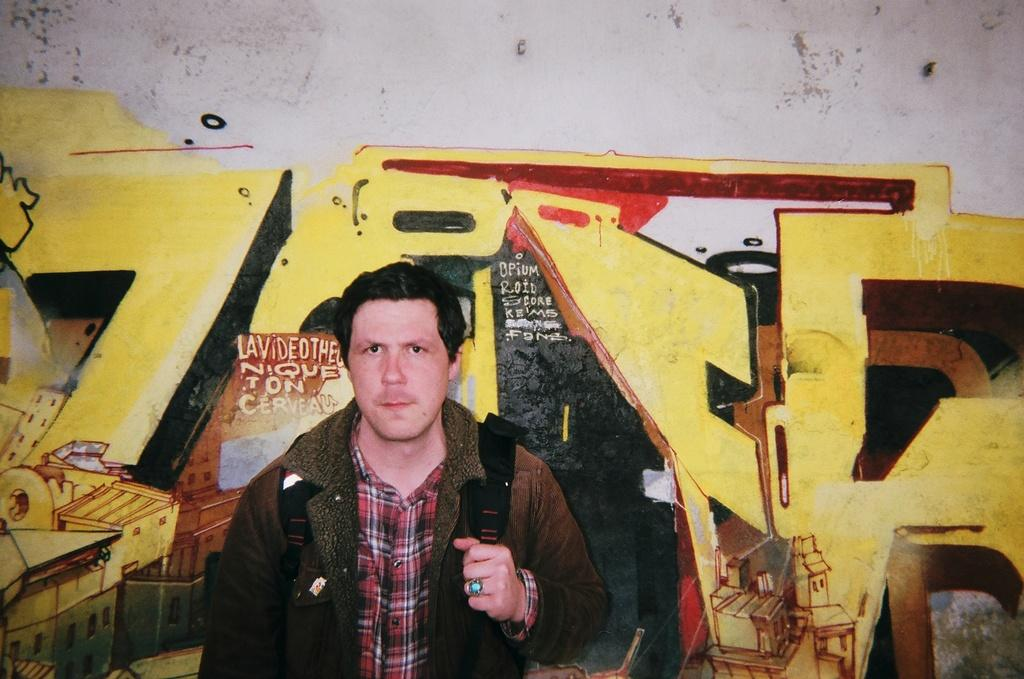What is present in the image? There is a man in the image. What is the man doing in the image? The man is standing in the image. What is the man holding in the image? The man is holding a bag in the image. What can be seen in the background of the image? There is a painted wall in the background of the image. What type of pear is the man holding in the image? The man is not holding a pear in the image; he is holding a bag. What type of servant is present in the image? There is no servant present in the image; it only features a man standing and holding a bag. 